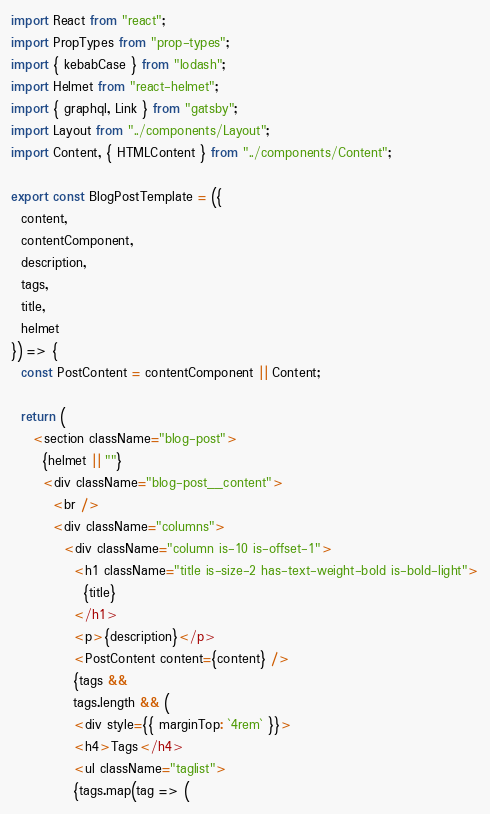Convert code to text. <code><loc_0><loc_0><loc_500><loc_500><_JavaScript_>import React from "react";
import PropTypes from "prop-types";
import { kebabCase } from "lodash";
import Helmet from "react-helmet";
import { graphql, Link } from "gatsby";
import Layout from "../components/Layout";
import Content, { HTMLContent } from "../components/Content";

export const BlogPostTemplate = ({
  content,
  contentComponent,
  description,
  tags,
  title,
  helmet
}) => {
  const PostContent = contentComponent || Content;

  return (
    <section className="blog-post">
      {helmet || ""}
      <div className="blog-post__content">
        <br />
        <div className="columns">
          <div className="column is-10 is-offset-1">
            <h1 className="title is-size-2 has-text-weight-bold is-bold-light">
              {title}
            </h1>
            <p>{description}</p>
            <PostContent content={content} />
            {tags &&
            tags.length && (
            <div style={{ marginTop: `4rem` }}>
            <h4>Tags</h4>
            <ul className="taglist">
            {tags.map(tag => (</code> 